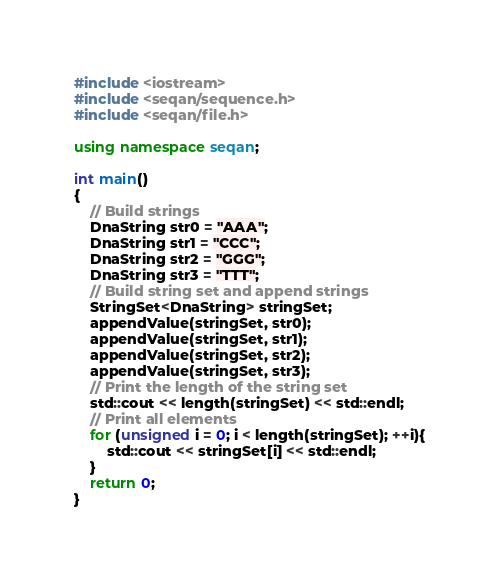Convert code to text. <code><loc_0><loc_0><loc_500><loc_500><_C++_>#include <iostream>
#include <seqan/sequence.h>
#include <seqan/file.h>

using namespace seqan;

int main()
{
    // Build strings
    DnaString str0 = "AAA";
    DnaString str1 = "CCC"; 
    DnaString str2 = "GGG"; 
    DnaString str3 = "TTT"; 
    // Build string set and append strings
    StringSet<DnaString> stringSet;
    appendValue(stringSet, str0);
    appendValue(stringSet, str1);
    appendValue(stringSet, str2);
    appendValue(stringSet, str3);
    // Print the length of the string set
    std::cout << length(stringSet) << std::endl;
    // Print all elements 
    for (unsigned i = 0; i < length(stringSet); ++i){
        std::cout << stringSet[i] << std::endl;
    }
    return 0;
}
</code> 